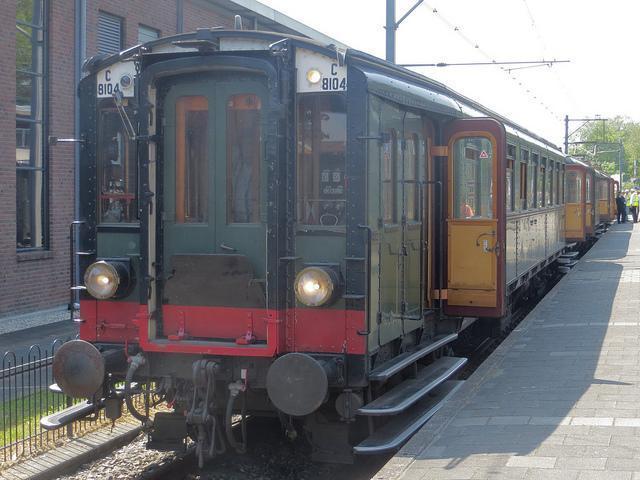How many doors are open?
Give a very brief answer. 5. How many bears are white?
Give a very brief answer. 0. 